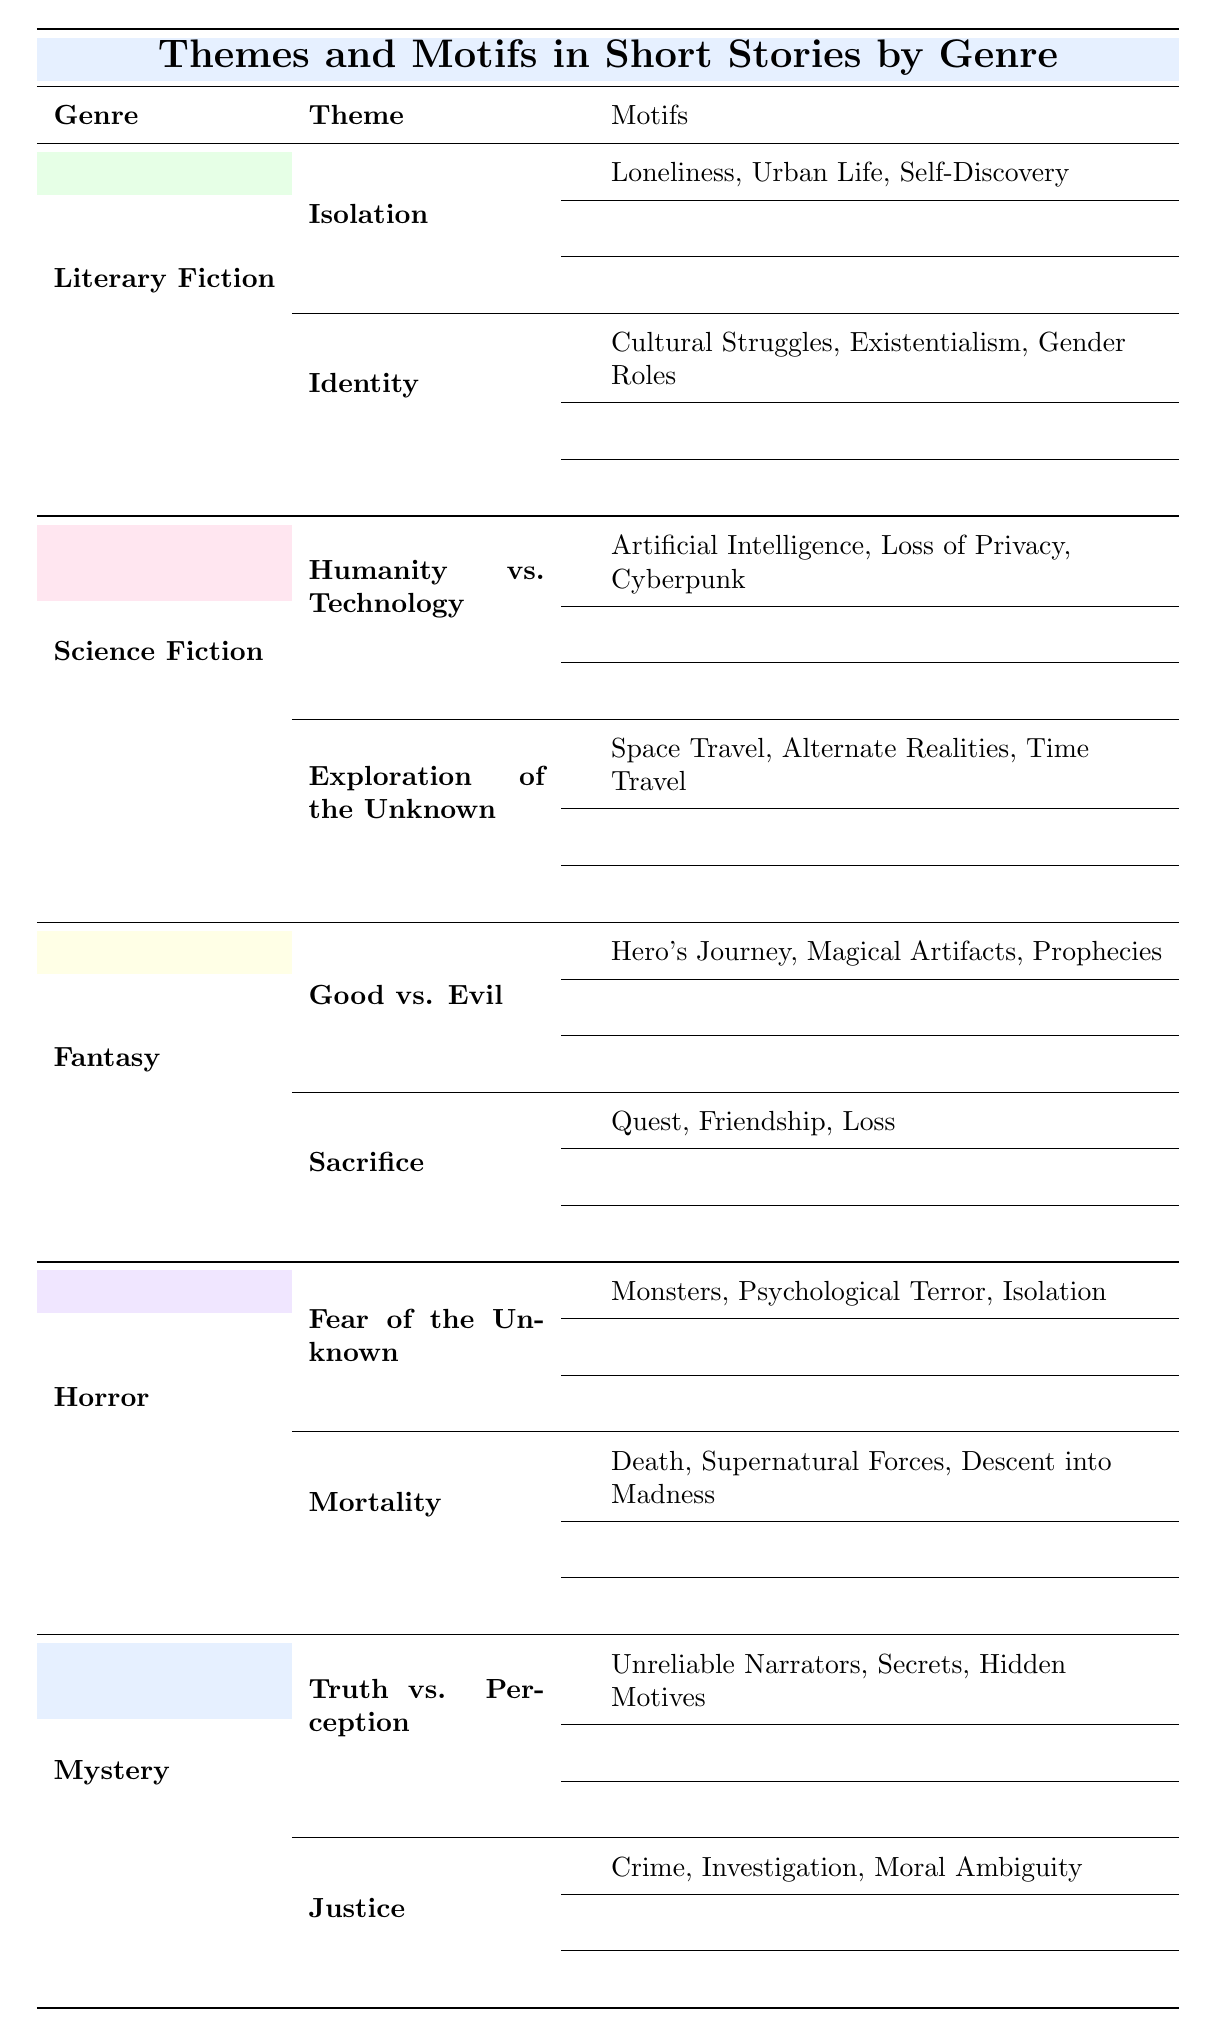What are the primary themes in Literary Fiction? The table indicates that the primary themes in Literary Fiction are Isolation and Identity.
Answer: Isolation, Identity In which genre is the theme "Good vs. Evil" found? According to the table, the theme "Good vs. Evil" is located under the Fantasy genre.
Answer: Fantasy What motifs accompany the theme of "Humanity vs. Technology"? The motifs that accompany the theme "Humanity vs. Technology" are Artificial Intelligence, Loss of Privacy, and Cyberpunk.
Answer: Artificial Intelligence, Loss of Privacy, Cyberpunk Does the Horror genre contain a theme centered around "Mortality"? Yes, the table states that Mortality is indeed a theme found in the Horror genre.
Answer: Yes How many distinct themes are listed for the Mystery genre? The table shows that there are two themes listed under the Mystery genre: Truth vs. Perception and Justice.
Answer: 2 What is the average number of motifs per theme across all genres? Each genre has two themes, and each theme is listed with three motifs. There are 5 genres, so the total motifs are 6 themes multiplied by 3 motifs each, which equals 18. Dividing the total (18) by the number of themes (6) yields an average of 3 motifs per theme.
Answer: 3 What motifs are associated with the theme "Sacrifice"? The motifs associated with the theme "Sacrifice" are Quest, Friendship, and Loss.
Answer: Quest, Friendship, Loss Which genre has the most themes based on the table? The table indicates that all genres have two themes listed, thus they are all equal in the number of themes.
Answer: None (equal themes across genres) Is "Exploration of the Unknown" a theme in both Science Fiction and Fantasy genres? No, "Exploration of the Unknown" is exclusively found in the Science Fiction genre according to the table.
Answer: No 